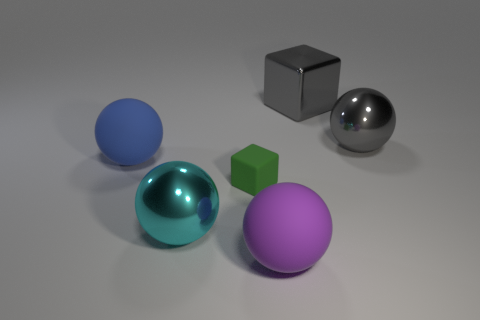Subtract 1 balls. How many balls are left? 3 Add 2 metal objects. How many objects exist? 8 Subtract all blocks. How many objects are left? 4 Add 6 blue rubber objects. How many blue rubber objects exist? 7 Subtract 1 purple spheres. How many objects are left? 5 Subtract all tiny brown cylinders. Subtract all small matte objects. How many objects are left? 5 Add 1 blue objects. How many blue objects are left? 2 